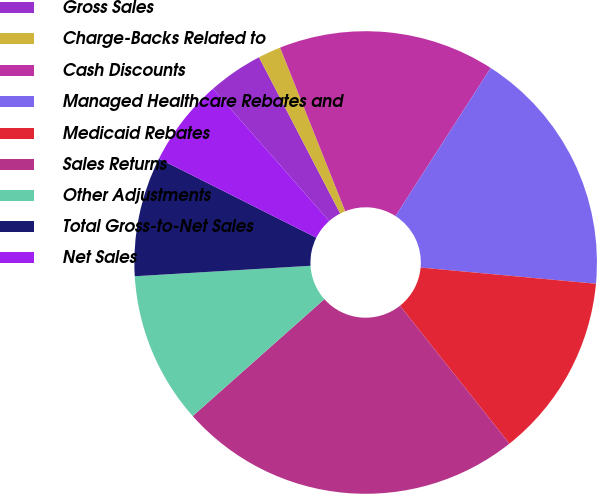Convert chart to OTSL. <chart><loc_0><loc_0><loc_500><loc_500><pie_chart><fcel>Gross Sales<fcel>Charge-Backs Related to<fcel>Cash Discounts<fcel>Managed Healthcare Rebates and<fcel>Medicaid Rebates<fcel>Sales Returns<fcel>Other Adjustments<fcel>Total Gross-to-Net Sales<fcel>Net Sales<nl><fcel>3.85%<fcel>1.6%<fcel>15.12%<fcel>17.37%<fcel>12.86%<fcel>24.12%<fcel>10.61%<fcel>8.36%<fcel>6.11%<nl></chart> 